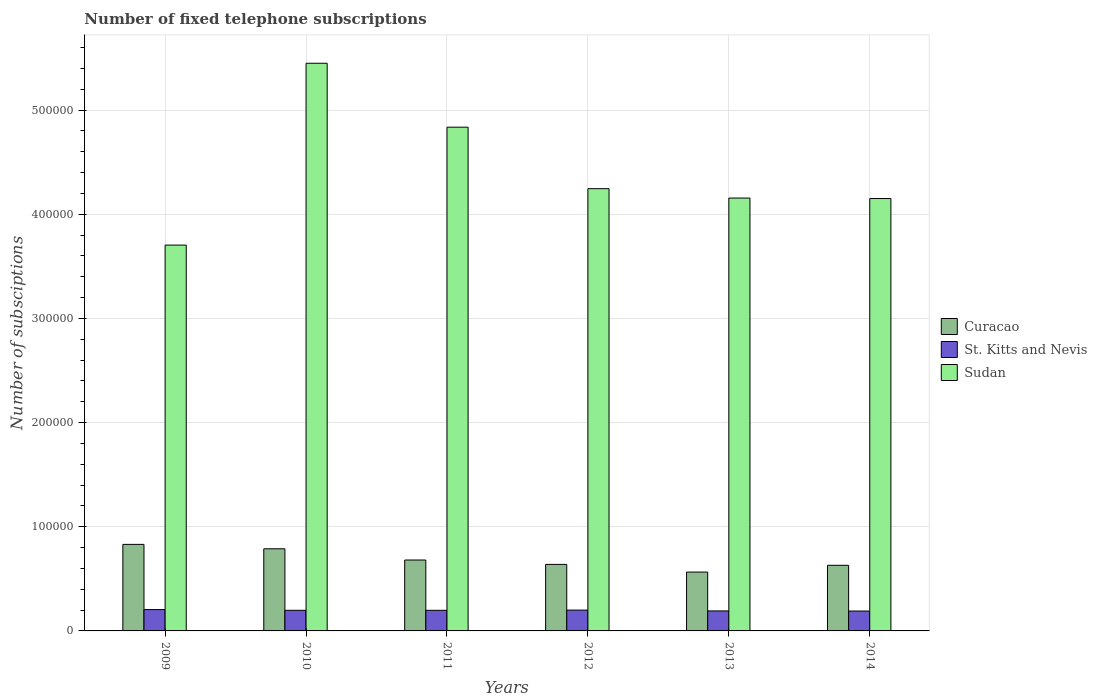Are the number of bars per tick equal to the number of legend labels?
Offer a very short reply. Yes. Are the number of bars on each tick of the X-axis equal?
Your response must be concise. Yes. How many bars are there on the 2nd tick from the right?
Ensure brevity in your answer.  3. What is the label of the 1st group of bars from the left?
Offer a terse response. 2009. What is the number of fixed telephone subscriptions in St. Kitts and Nevis in 2014?
Your response must be concise. 1.91e+04. Across all years, what is the maximum number of fixed telephone subscriptions in St. Kitts and Nevis?
Provide a succinct answer. 2.05e+04. Across all years, what is the minimum number of fixed telephone subscriptions in Sudan?
Your response must be concise. 3.70e+05. In which year was the number of fixed telephone subscriptions in Curacao maximum?
Your answer should be very brief. 2009. In which year was the number of fixed telephone subscriptions in Curacao minimum?
Provide a succinct answer. 2013. What is the total number of fixed telephone subscriptions in St. Kitts and Nevis in the graph?
Ensure brevity in your answer.  1.18e+05. What is the difference between the number of fixed telephone subscriptions in St. Kitts and Nevis in 2010 and that in 2012?
Your answer should be compact. -200. What is the difference between the number of fixed telephone subscriptions in Curacao in 2010 and the number of fixed telephone subscriptions in St. Kitts and Nevis in 2014?
Provide a short and direct response. 5.97e+04. What is the average number of fixed telephone subscriptions in St. Kitts and Nevis per year?
Your answer should be very brief. 1.97e+04. In the year 2014, what is the difference between the number of fixed telephone subscriptions in Curacao and number of fixed telephone subscriptions in St. Kitts and Nevis?
Make the answer very short. 4.39e+04. What is the ratio of the number of fixed telephone subscriptions in Curacao in 2009 to that in 2013?
Offer a terse response. 1.47. Is the number of fixed telephone subscriptions in Sudan in 2010 less than that in 2012?
Provide a short and direct response. No. Is the difference between the number of fixed telephone subscriptions in Curacao in 2010 and 2011 greater than the difference between the number of fixed telephone subscriptions in St. Kitts and Nevis in 2010 and 2011?
Make the answer very short. Yes. What is the difference between the highest and the second highest number of fixed telephone subscriptions in Curacao?
Your response must be concise. 4234. What is the difference between the highest and the lowest number of fixed telephone subscriptions in Sudan?
Your answer should be compact. 1.75e+05. What does the 1st bar from the left in 2011 represents?
Offer a terse response. Curacao. What does the 3rd bar from the right in 2010 represents?
Your answer should be compact. Curacao. Is it the case that in every year, the sum of the number of fixed telephone subscriptions in St. Kitts and Nevis and number of fixed telephone subscriptions in Curacao is greater than the number of fixed telephone subscriptions in Sudan?
Give a very brief answer. No. How many bars are there?
Your answer should be very brief. 18. Are all the bars in the graph horizontal?
Offer a terse response. No. How many years are there in the graph?
Offer a very short reply. 6. Does the graph contain any zero values?
Offer a very short reply. No. Where does the legend appear in the graph?
Provide a short and direct response. Center right. How are the legend labels stacked?
Ensure brevity in your answer.  Vertical. What is the title of the graph?
Keep it short and to the point. Number of fixed telephone subscriptions. What is the label or title of the Y-axis?
Offer a very short reply. Number of subsciptions. What is the Number of subsciptions in Curacao in 2009?
Offer a terse response. 8.31e+04. What is the Number of subsciptions in St. Kitts and Nevis in 2009?
Make the answer very short. 2.05e+04. What is the Number of subsciptions in Sudan in 2009?
Keep it short and to the point. 3.70e+05. What is the Number of subsciptions of Curacao in 2010?
Make the answer very short. 7.88e+04. What is the Number of subsciptions in St. Kitts and Nevis in 2010?
Keep it short and to the point. 1.98e+04. What is the Number of subsciptions of Sudan in 2010?
Offer a terse response. 5.45e+05. What is the Number of subsciptions of Curacao in 2011?
Give a very brief answer. 6.81e+04. What is the Number of subsciptions of St. Kitts and Nevis in 2011?
Keep it short and to the point. 1.98e+04. What is the Number of subsciptions in Sudan in 2011?
Give a very brief answer. 4.84e+05. What is the Number of subsciptions in Curacao in 2012?
Offer a very short reply. 6.39e+04. What is the Number of subsciptions of Sudan in 2012?
Offer a terse response. 4.25e+05. What is the Number of subsciptions of Curacao in 2013?
Provide a succinct answer. 5.65e+04. What is the Number of subsciptions of St. Kitts and Nevis in 2013?
Keep it short and to the point. 1.92e+04. What is the Number of subsciptions of Sudan in 2013?
Ensure brevity in your answer.  4.16e+05. What is the Number of subsciptions in Curacao in 2014?
Your answer should be compact. 6.30e+04. What is the Number of subsciptions in St. Kitts and Nevis in 2014?
Your answer should be very brief. 1.91e+04. What is the Number of subsciptions of Sudan in 2014?
Offer a terse response. 4.15e+05. Across all years, what is the maximum Number of subsciptions in Curacao?
Offer a terse response. 8.31e+04. Across all years, what is the maximum Number of subsciptions of St. Kitts and Nevis?
Provide a short and direct response. 2.05e+04. Across all years, what is the maximum Number of subsciptions of Sudan?
Make the answer very short. 5.45e+05. Across all years, what is the minimum Number of subsciptions of Curacao?
Ensure brevity in your answer.  5.65e+04. Across all years, what is the minimum Number of subsciptions in St. Kitts and Nevis?
Offer a terse response. 1.91e+04. Across all years, what is the minimum Number of subsciptions in Sudan?
Your answer should be very brief. 3.70e+05. What is the total Number of subsciptions of Curacao in the graph?
Provide a succinct answer. 4.13e+05. What is the total Number of subsciptions of St. Kitts and Nevis in the graph?
Offer a very short reply. 1.18e+05. What is the total Number of subsciptions in Sudan in the graph?
Ensure brevity in your answer.  2.65e+06. What is the difference between the Number of subsciptions in Curacao in 2009 and that in 2010?
Make the answer very short. 4234. What is the difference between the Number of subsciptions in St. Kitts and Nevis in 2009 and that in 2010?
Your response must be concise. 700. What is the difference between the Number of subsciptions of Sudan in 2009 and that in 2010?
Your answer should be very brief. -1.75e+05. What is the difference between the Number of subsciptions in Curacao in 2009 and that in 2011?
Ensure brevity in your answer.  1.50e+04. What is the difference between the Number of subsciptions in St. Kitts and Nevis in 2009 and that in 2011?
Your response must be concise. 700. What is the difference between the Number of subsciptions of Sudan in 2009 and that in 2011?
Ensure brevity in your answer.  -1.13e+05. What is the difference between the Number of subsciptions of Curacao in 2009 and that in 2012?
Give a very brief answer. 1.92e+04. What is the difference between the Number of subsciptions in Sudan in 2009 and that in 2012?
Provide a short and direct response. -5.42e+04. What is the difference between the Number of subsciptions in Curacao in 2009 and that in 2013?
Provide a short and direct response. 2.66e+04. What is the difference between the Number of subsciptions in St. Kitts and Nevis in 2009 and that in 2013?
Keep it short and to the point. 1300. What is the difference between the Number of subsciptions in Sudan in 2009 and that in 2013?
Provide a short and direct response. -4.51e+04. What is the difference between the Number of subsciptions in Curacao in 2009 and that in 2014?
Make the answer very short. 2.01e+04. What is the difference between the Number of subsciptions in St. Kitts and Nevis in 2009 and that in 2014?
Your answer should be compact. 1400. What is the difference between the Number of subsciptions of Sudan in 2009 and that in 2014?
Offer a terse response. -4.47e+04. What is the difference between the Number of subsciptions in Curacao in 2010 and that in 2011?
Offer a very short reply. 1.08e+04. What is the difference between the Number of subsciptions of Sudan in 2010 and that in 2011?
Keep it short and to the point. 6.14e+04. What is the difference between the Number of subsciptions of Curacao in 2010 and that in 2012?
Provide a succinct answer. 1.50e+04. What is the difference between the Number of subsciptions of St. Kitts and Nevis in 2010 and that in 2012?
Provide a short and direct response. -200. What is the difference between the Number of subsciptions of Sudan in 2010 and that in 2012?
Your answer should be very brief. 1.20e+05. What is the difference between the Number of subsciptions of Curacao in 2010 and that in 2013?
Give a very brief answer. 2.23e+04. What is the difference between the Number of subsciptions in St. Kitts and Nevis in 2010 and that in 2013?
Your response must be concise. 600. What is the difference between the Number of subsciptions in Sudan in 2010 and that in 2013?
Make the answer very short. 1.29e+05. What is the difference between the Number of subsciptions of Curacao in 2010 and that in 2014?
Provide a short and direct response. 1.58e+04. What is the difference between the Number of subsciptions of St. Kitts and Nevis in 2010 and that in 2014?
Offer a very short reply. 700. What is the difference between the Number of subsciptions in Sudan in 2010 and that in 2014?
Keep it short and to the point. 1.30e+05. What is the difference between the Number of subsciptions of Curacao in 2011 and that in 2012?
Keep it short and to the point. 4202. What is the difference between the Number of subsciptions in St. Kitts and Nevis in 2011 and that in 2012?
Your answer should be very brief. -200. What is the difference between the Number of subsciptions in Sudan in 2011 and that in 2012?
Your response must be concise. 5.90e+04. What is the difference between the Number of subsciptions of Curacao in 2011 and that in 2013?
Provide a short and direct response. 1.16e+04. What is the difference between the Number of subsciptions in St. Kitts and Nevis in 2011 and that in 2013?
Your response must be concise. 600. What is the difference between the Number of subsciptions in Sudan in 2011 and that in 2013?
Your answer should be compact. 6.80e+04. What is the difference between the Number of subsciptions of Curacao in 2011 and that in 2014?
Give a very brief answer. 5070. What is the difference between the Number of subsciptions in St. Kitts and Nevis in 2011 and that in 2014?
Ensure brevity in your answer.  700. What is the difference between the Number of subsciptions in Sudan in 2011 and that in 2014?
Ensure brevity in your answer.  6.85e+04. What is the difference between the Number of subsciptions in Curacao in 2012 and that in 2013?
Make the answer very short. 7368. What is the difference between the Number of subsciptions in St. Kitts and Nevis in 2012 and that in 2013?
Offer a terse response. 800. What is the difference between the Number of subsciptions of Sudan in 2012 and that in 2013?
Give a very brief answer. 9015. What is the difference between the Number of subsciptions in Curacao in 2012 and that in 2014?
Provide a short and direct response. 868. What is the difference between the Number of subsciptions in St. Kitts and Nevis in 2012 and that in 2014?
Keep it short and to the point. 900. What is the difference between the Number of subsciptions in Sudan in 2012 and that in 2014?
Keep it short and to the point. 9480. What is the difference between the Number of subsciptions of Curacao in 2013 and that in 2014?
Your answer should be very brief. -6500. What is the difference between the Number of subsciptions of Sudan in 2013 and that in 2014?
Ensure brevity in your answer.  465. What is the difference between the Number of subsciptions in Curacao in 2009 and the Number of subsciptions in St. Kitts and Nevis in 2010?
Provide a short and direct response. 6.33e+04. What is the difference between the Number of subsciptions of Curacao in 2009 and the Number of subsciptions of Sudan in 2010?
Your response must be concise. -4.62e+05. What is the difference between the Number of subsciptions of St. Kitts and Nevis in 2009 and the Number of subsciptions of Sudan in 2010?
Your response must be concise. -5.24e+05. What is the difference between the Number of subsciptions of Curacao in 2009 and the Number of subsciptions of St. Kitts and Nevis in 2011?
Make the answer very short. 6.33e+04. What is the difference between the Number of subsciptions of Curacao in 2009 and the Number of subsciptions of Sudan in 2011?
Ensure brevity in your answer.  -4.01e+05. What is the difference between the Number of subsciptions in St. Kitts and Nevis in 2009 and the Number of subsciptions in Sudan in 2011?
Offer a terse response. -4.63e+05. What is the difference between the Number of subsciptions of Curacao in 2009 and the Number of subsciptions of St. Kitts and Nevis in 2012?
Make the answer very short. 6.31e+04. What is the difference between the Number of subsciptions in Curacao in 2009 and the Number of subsciptions in Sudan in 2012?
Make the answer very short. -3.42e+05. What is the difference between the Number of subsciptions in St. Kitts and Nevis in 2009 and the Number of subsciptions in Sudan in 2012?
Your answer should be very brief. -4.04e+05. What is the difference between the Number of subsciptions of Curacao in 2009 and the Number of subsciptions of St. Kitts and Nevis in 2013?
Offer a very short reply. 6.39e+04. What is the difference between the Number of subsciptions of Curacao in 2009 and the Number of subsciptions of Sudan in 2013?
Your answer should be compact. -3.32e+05. What is the difference between the Number of subsciptions in St. Kitts and Nevis in 2009 and the Number of subsciptions in Sudan in 2013?
Provide a short and direct response. -3.95e+05. What is the difference between the Number of subsciptions in Curacao in 2009 and the Number of subsciptions in St. Kitts and Nevis in 2014?
Your answer should be very brief. 6.40e+04. What is the difference between the Number of subsciptions in Curacao in 2009 and the Number of subsciptions in Sudan in 2014?
Your answer should be compact. -3.32e+05. What is the difference between the Number of subsciptions in St. Kitts and Nevis in 2009 and the Number of subsciptions in Sudan in 2014?
Provide a succinct answer. -3.95e+05. What is the difference between the Number of subsciptions of Curacao in 2010 and the Number of subsciptions of St. Kitts and Nevis in 2011?
Your response must be concise. 5.90e+04. What is the difference between the Number of subsciptions in Curacao in 2010 and the Number of subsciptions in Sudan in 2011?
Make the answer very short. -4.05e+05. What is the difference between the Number of subsciptions in St. Kitts and Nevis in 2010 and the Number of subsciptions in Sudan in 2011?
Offer a very short reply. -4.64e+05. What is the difference between the Number of subsciptions in Curacao in 2010 and the Number of subsciptions in St. Kitts and Nevis in 2012?
Offer a terse response. 5.88e+04. What is the difference between the Number of subsciptions of Curacao in 2010 and the Number of subsciptions of Sudan in 2012?
Provide a short and direct response. -3.46e+05. What is the difference between the Number of subsciptions of St. Kitts and Nevis in 2010 and the Number of subsciptions of Sudan in 2012?
Make the answer very short. -4.05e+05. What is the difference between the Number of subsciptions of Curacao in 2010 and the Number of subsciptions of St. Kitts and Nevis in 2013?
Make the answer very short. 5.96e+04. What is the difference between the Number of subsciptions in Curacao in 2010 and the Number of subsciptions in Sudan in 2013?
Give a very brief answer. -3.37e+05. What is the difference between the Number of subsciptions of St. Kitts and Nevis in 2010 and the Number of subsciptions of Sudan in 2013?
Offer a terse response. -3.96e+05. What is the difference between the Number of subsciptions in Curacao in 2010 and the Number of subsciptions in St. Kitts and Nevis in 2014?
Your response must be concise. 5.97e+04. What is the difference between the Number of subsciptions of Curacao in 2010 and the Number of subsciptions of Sudan in 2014?
Your answer should be very brief. -3.36e+05. What is the difference between the Number of subsciptions of St. Kitts and Nevis in 2010 and the Number of subsciptions of Sudan in 2014?
Ensure brevity in your answer.  -3.95e+05. What is the difference between the Number of subsciptions in Curacao in 2011 and the Number of subsciptions in St. Kitts and Nevis in 2012?
Your response must be concise. 4.81e+04. What is the difference between the Number of subsciptions in Curacao in 2011 and the Number of subsciptions in Sudan in 2012?
Your response must be concise. -3.57e+05. What is the difference between the Number of subsciptions of St. Kitts and Nevis in 2011 and the Number of subsciptions of Sudan in 2012?
Give a very brief answer. -4.05e+05. What is the difference between the Number of subsciptions of Curacao in 2011 and the Number of subsciptions of St. Kitts and Nevis in 2013?
Your answer should be very brief. 4.89e+04. What is the difference between the Number of subsciptions of Curacao in 2011 and the Number of subsciptions of Sudan in 2013?
Make the answer very short. -3.48e+05. What is the difference between the Number of subsciptions in St. Kitts and Nevis in 2011 and the Number of subsciptions in Sudan in 2013?
Your response must be concise. -3.96e+05. What is the difference between the Number of subsciptions in Curacao in 2011 and the Number of subsciptions in St. Kitts and Nevis in 2014?
Offer a very short reply. 4.90e+04. What is the difference between the Number of subsciptions of Curacao in 2011 and the Number of subsciptions of Sudan in 2014?
Keep it short and to the point. -3.47e+05. What is the difference between the Number of subsciptions in St. Kitts and Nevis in 2011 and the Number of subsciptions in Sudan in 2014?
Ensure brevity in your answer.  -3.95e+05. What is the difference between the Number of subsciptions of Curacao in 2012 and the Number of subsciptions of St. Kitts and Nevis in 2013?
Offer a very short reply. 4.47e+04. What is the difference between the Number of subsciptions in Curacao in 2012 and the Number of subsciptions in Sudan in 2013?
Provide a succinct answer. -3.52e+05. What is the difference between the Number of subsciptions of St. Kitts and Nevis in 2012 and the Number of subsciptions of Sudan in 2013?
Keep it short and to the point. -3.96e+05. What is the difference between the Number of subsciptions in Curacao in 2012 and the Number of subsciptions in St. Kitts and Nevis in 2014?
Your answer should be very brief. 4.48e+04. What is the difference between the Number of subsciptions in Curacao in 2012 and the Number of subsciptions in Sudan in 2014?
Make the answer very short. -3.51e+05. What is the difference between the Number of subsciptions in St. Kitts and Nevis in 2012 and the Number of subsciptions in Sudan in 2014?
Ensure brevity in your answer.  -3.95e+05. What is the difference between the Number of subsciptions in Curacao in 2013 and the Number of subsciptions in St. Kitts and Nevis in 2014?
Ensure brevity in your answer.  3.74e+04. What is the difference between the Number of subsciptions in Curacao in 2013 and the Number of subsciptions in Sudan in 2014?
Offer a terse response. -3.59e+05. What is the difference between the Number of subsciptions in St. Kitts and Nevis in 2013 and the Number of subsciptions in Sudan in 2014?
Your answer should be very brief. -3.96e+05. What is the average Number of subsciptions in Curacao per year?
Ensure brevity in your answer.  6.89e+04. What is the average Number of subsciptions in St. Kitts and Nevis per year?
Provide a succinct answer. 1.97e+04. What is the average Number of subsciptions of Sudan per year?
Provide a succinct answer. 4.42e+05. In the year 2009, what is the difference between the Number of subsciptions of Curacao and Number of subsciptions of St. Kitts and Nevis?
Keep it short and to the point. 6.26e+04. In the year 2009, what is the difference between the Number of subsciptions in Curacao and Number of subsciptions in Sudan?
Your answer should be compact. -2.87e+05. In the year 2009, what is the difference between the Number of subsciptions in St. Kitts and Nevis and Number of subsciptions in Sudan?
Give a very brief answer. -3.50e+05. In the year 2010, what is the difference between the Number of subsciptions of Curacao and Number of subsciptions of St. Kitts and Nevis?
Ensure brevity in your answer.  5.90e+04. In the year 2010, what is the difference between the Number of subsciptions of Curacao and Number of subsciptions of Sudan?
Provide a succinct answer. -4.66e+05. In the year 2010, what is the difference between the Number of subsciptions in St. Kitts and Nevis and Number of subsciptions in Sudan?
Provide a short and direct response. -5.25e+05. In the year 2011, what is the difference between the Number of subsciptions of Curacao and Number of subsciptions of St. Kitts and Nevis?
Offer a terse response. 4.83e+04. In the year 2011, what is the difference between the Number of subsciptions of Curacao and Number of subsciptions of Sudan?
Your answer should be very brief. -4.16e+05. In the year 2011, what is the difference between the Number of subsciptions in St. Kitts and Nevis and Number of subsciptions in Sudan?
Offer a very short reply. -4.64e+05. In the year 2012, what is the difference between the Number of subsciptions of Curacao and Number of subsciptions of St. Kitts and Nevis?
Give a very brief answer. 4.39e+04. In the year 2012, what is the difference between the Number of subsciptions of Curacao and Number of subsciptions of Sudan?
Ensure brevity in your answer.  -3.61e+05. In the year 2012, what is the difference between the Number of subsciptions of St. Kitts and Nevis and Number of subsciptions of Sudan?
Make the answer very short. -4.05e+05. In the year 2013, what is the difference between the Number of subsciptions in Curacao and Number of subsciptions in St. Kitts and Nevis?
Keep it short and to the point. 3.73e+04. In the year 2013, what is the difference between the Number of subsciptions of Curacao and Number of subsciptions of Sudan?
Keep it short and to the point. -3.59e+05. In the year 2013, what is the difference between the Number of subsciptions of St. Kitts and Nevis and Number of subsciptions of Sudan?
Keep it short and to the point. -3.96e+05. In the year 2014, what is the difference between the Number of subsciptions of Curacao and Number of subsciptions of St. Kitts and Nevis?
Offer a very short reply. 4.39e+04. In the year 2014, what is the difference between the Number of subsciptions in Curacao and Number of subsciptions in Sudan?
Make the answer very short. -3.52e+05. In the year 2014, what is the difference between the Number of subsciptions in St. Kitts and Nevis and Number of subsciptions in Sudan?
Offer a very short reply. -3.96e+05. What is the ratio of the Number of subsciptions of Curacao in 2009 to that in 2010?
Provide a short and direct response. 1.05. What is the ratio of the Number of subsciptions in St. Kitts and Nevis in 2009 to that in 2010?
Give a very brief answer. 1.04. What is the ratio of the Number of subsciptions in Sudan in 2009 to that in 2010?
Your answer should be very brief. 0.68. What is the ratio of the Number of subsciptions in Curacao in 2009 to that in 2011?
Provide a short and direct response. 1.22. What is the ratio of the Number of subsciptions in St. Kitts and Nevis in 2009 to that in 2011?
Give a very brief answer. 1.04. What is the ratio of the Number of subsciptions of Sudan in 2009 to that in 2011?
Give a very brief answer. 0.77. What is the ratio of the Number of subsciptions in Curacao in 2009 to that in 2012?
Your answer should be compact. 1.3. What is the ratio of the Number of subsciptions in St. Kitts and Nevis in 2009 to that in 2012?
Your answer should be very brief. 1.02. What is the ratio of the Number of subsciptions in Sudan in 2009 to that in 2012?
Ensure brevity in your answer.  0.87. What is the ratio of the Number of subsciptions in Curacao in 2009 to that in 2013?
Your response must be concise. 1.47. What is the ratio of the Number of subsciptions in St. Kitts and Nevis in 2009 to that in 2013?
Your answer should be very brief. 1.07. What is the ratio of the Number of subsciptions of Sudan in 2009 to that in 2013?
Offer a very short reply. 0.89. What is the ratio of the Number of subsciptions of Curacao in 2009 to that in 2014?
Offer a terse response. 1.32. What is the ratio of the Number of subsciptions of St. Kitts and Nevis in 2009 to that in 2014?
Keep it short and to the point. 1.07. What is the ratio of the Number of subsciptions in Sudan in 2009 to that in 2014?
Your answer should be compact. 0.89. What is the ratio of the Number of subsciptions of Curacao in 2010 to that in 2011?
Keep it short and to the point. 1.16. What is the ratio of the Number of subsciptions of Sudan in 2010 to that in 2011?
Keep it short and to the point. 1.13. What is the ratio of the Number of subsciptions of Curacao in 2010 to that in 2012?
Give a very brief answer. 1.23. What is the ratio of the Number of subsciptions of Sudan in 2010 to that in 2012?
Your answer should be very brief. 1.28. What is the ratio of the Number of subsciptions of Curacao in 2010 to that in 2013?
Provide a short and direct response. 1.4. What is the ratio of the Number of subsciptions of St. Kitts and Nevis in 2010 to that in 2013?
Offer a terse response. 1.03. What is the ratio of the Number of subsciptions in Sudan in 2010 to that in 2013?
Provide a short and direct response. 1.31. What is the ratio of the Number of subsciptions of Curacao in 2010 to that in 2014?
Offer a terse response. 1.25. What is the ratio of the Number of subsciptions of St. Kitts and Nevis in 2010 to that in 2014?
Your response must be concise. 1.04. What is the ratio of the Number of subsciptions in Sudan in 2010 to that in 2014?
Your answer should be very brief. 1.31. What is the ratio of the Number of subsciptions of Curacao in 2011 to that in 2012?
Your response must be concise. 1.07. What is the ratio of the Number of subsciptions of Sudan in 2011 to that in 2012?
Make the answer very short. 1.14. What is the ratio of the Number of subsciptions in Curacao in 2011 to that in 2013?
Your answer should be very brief. 1.2. What is the ratio of the Number of subsciptions of St. Kitts and Nevis in 2011 to that in 2013?
Your answer should be compact. 1.03. What is the ratio of the Number of subsciptions in Sudan in 2011 to that in 2013?
Give a very brief answer. 1.16. What is the ratio of the Number of subsciptions in Curacao in 2011 to that in 2014?
Give a very brief answer. 1.08. What is the ratio of the Number of subsciptions in St. Kitts and Nevis in 2011 to that in 2014?
Provide a succinct answer. 1.04. What is the ratio of the Number of subsciptions of Sudan in 2011 to that in 2014?
Offer a terse response. 1.17. What is the ratio of the Number of subsciptions of Curacao in 2012 to that in 2013?
Offer a very short reply. 1.13. What is the ratio of the Number of subsciptions in St. Kitts and Nevis in 2012 to that in 2013?
Provide a succinct answer. 1.04. What is the ratio of the Number of subsciptions in Sudan in 2012 to that in 2013?
Offer a terse response. 1.02. What is the ratio of the Number of subsciptions in Curacao in 2012 to that in 2014?
Your response must be concise. 1.01. What is the ratio of the Number of subsciptions in St. Kitts and Nevis in 2012 to that in 2014?
Keep it short and to the point. 1.05. What is the ratio of the Number of subsciptions of Sudan in 2012 to that in 2014?
Your answer should be very brief. 1.02. What is the ratio of the Number of subsciptions in Curacao in 2013 to that in 2014?
Your response must be concise. 0.9. What is the ratio of the Number of subsciptions in St. Kitts and Nevis in 2013 to that in 2014?
Offer a very short reply. 1.01. What is the difference between the highest and the second highest Number of subsciptions of Curacao?
Provide a short and direct response. 4234. What is the difference between the highest and the second highest Number of subsciptions in Sudan?
Ensure brevity in your answer.  6.14e+04. What is the difference between the highest and the lowest Number of subsciptions in Curacao?
Your answer should be compact. 2.66e+04. What is the difference between the highest and the lowest Number of subsciptions of St. Kitts and Nevis?
Keep it short and to the point. 1400. What is the difference between the highest and the lowest Number of subsciptions in Sudan?
Provide a succinct answer. 1.75e+05. 